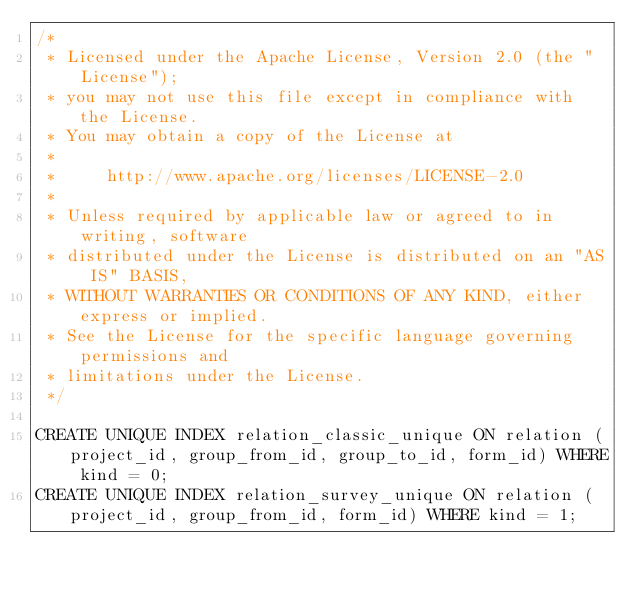Convert code to text. <code><loc_0><loc_0><loc_500><loc_500><_SQL_>/*
 * Licensed under the Apache License, Version 2.0 (the "License");
 * you may not use this file except in compliance with the License.
 * You may obtain a copy of the License at
 *
 *     http://www.apache.org/licenses/LICENSE-2.0
 *
 * Unless required by applicable law or agreed to in writing, software
 * distributed under the License is distributed on an "AS IS" BASIS,
 * WITHOUT WARRANTIES OR CONDITIONS OF ANY KIND, either express or implied.
 * See the License for the specific language governing permissions and
 * limitations under the License.
 */

CREATE UNIQUE INDEX relation_classic_unique ON relation (project_id, group_from_id, group_to_id, form_id) WHERE kind = 0;
CREATE UNIQUE INDEX relation_survey_unique ON relation (project_id, group_from_id, form_id) WHERE kind = 1;
</code> 